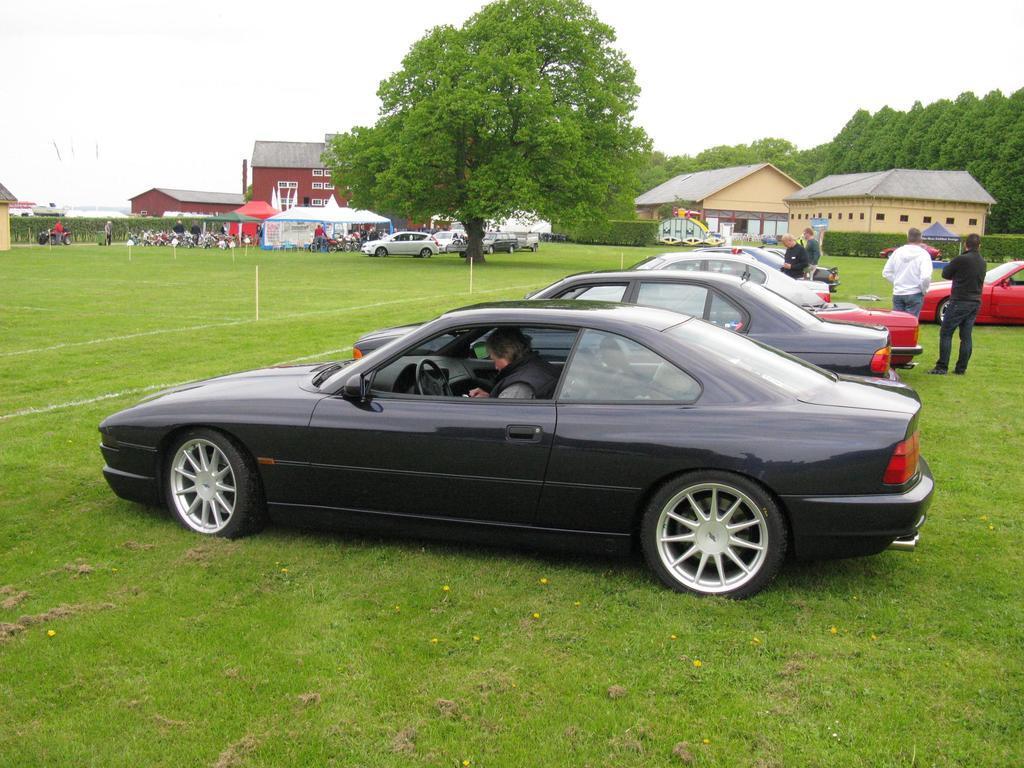Please provide a concise description of this image. This picture is clicked outside. In the foreground we can see a person sitting in the car and we can see the group of persons and we can see the cars seems to be parked on the ground and we can see the green grass, plants, trees, tents, houses and many other objects. In the background we can see the sky. 